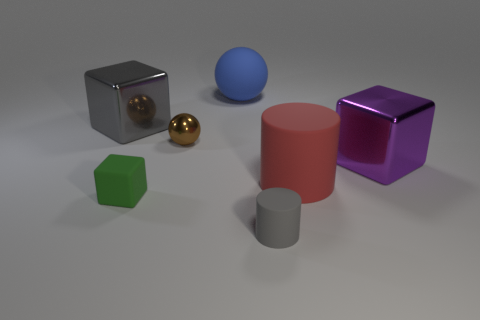What is the color of the large cylinder that is made of the same material as the blue ball?
Your answer should be very brief. Red. There is a big matte thing that is in front of the large metallic cube that is behind the large purple cube; what is its color?
Provide a succinct answer. Red. Are there any big objects of the same color as the tiny cylinder?
Offer a terse response. Yes. What is the shape of the purple shiny object that is the same size as the blue matte sphere?
Give a very brief answer. Cube. How many metal objects are to the right of the big rubber thing that is right of the big rubber sphere?
Provide a short and direct response. 1. Is the color of the tiny matte block the same as the big cylinder?
Offer a terse response. No. How many other objects are there of the same material as the tiny cylinder?
Keep it short and to the point. 3. What shape is the big thing in front of the big metal cube that is in front of the large gray shiny block?
Ensure brevity in your answer.  Cylinder. There is a gray thing that is right of the brown metallic sphere; what size is it?
Give a very brief answer. Small. Are the purple thing and the big blue object made of the same material?
Make the answer very short. No. 